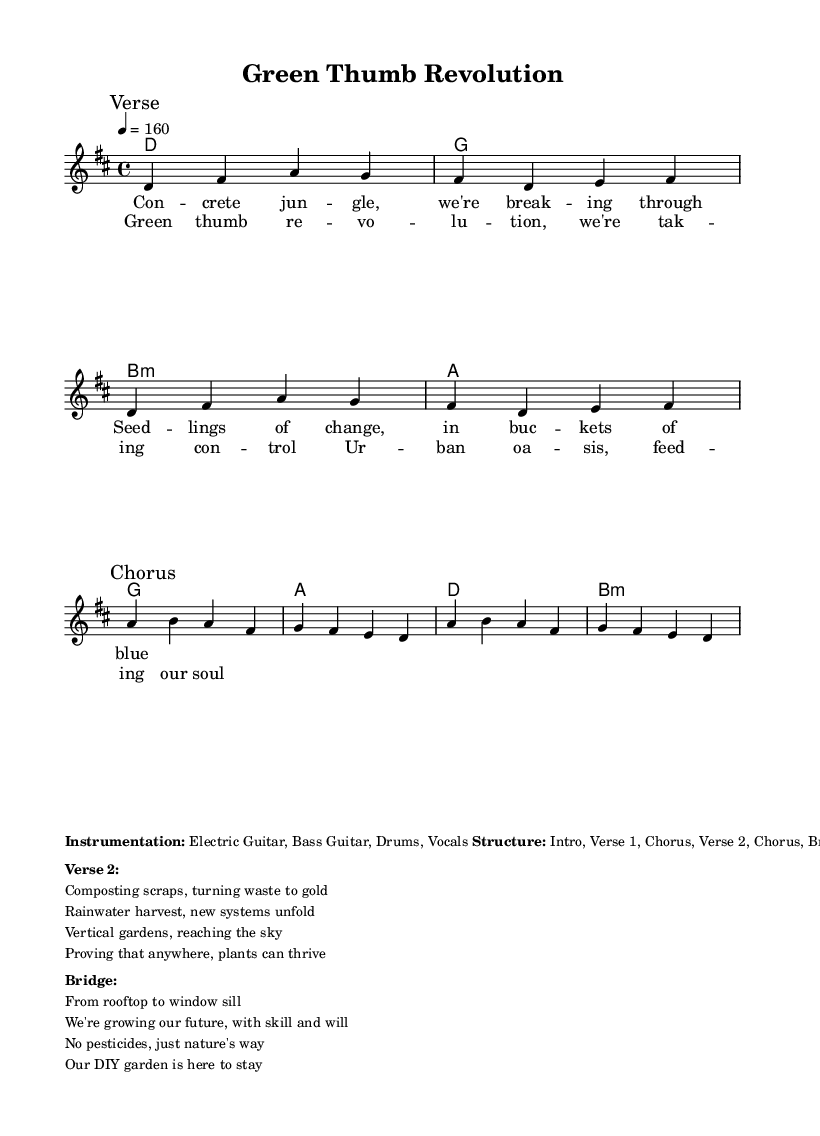What is the key signature of this music? The key signature is indicated at the beginning of the score. In this piece, the symbol for D major shows two sharps, which are C# and F#.
Answer: D major What is the time signature of the piece? The time signature is positioned at the beginning of the score. Here, 4/4 is shown, which means there are four beats in each measure, and the quarter note gets one beat.
Answer: 4/4 What is the tempo marking for the song? The tempo marking appears at the start of the score and indicates how fast the piece should be played. The marking shows 4 equals 160, meaning to play four beats per minute at 160 BPM.
Answer: 160 How many verses are there in the structure? The structure section of the score outlines the song's parts. It mentions “Intro, Verse 1, Chorus, Verse 2, Chorus, Bridge, Chorus, Outro,” implying there are two distinct verses in the song.
Answer: 2 What type of instruments are used in this song? The instrumentation section in the markup clearly states the instruments. It lists "Electric Guitar, Bass Guitar, Drums, Vocals" as the instrumentation for the piece.
Answer: Electric Guitar, Bass Guitar, Drums, Vocals What is the main theme of the song based on the lyrics? By examining the lyrics provided, the theme revolves around sustainable living and urban gardening. The specific phrases indicate the focus on growing plants and creating a positive impact on the environment.
Answer: Sustainable living and urban gardening 